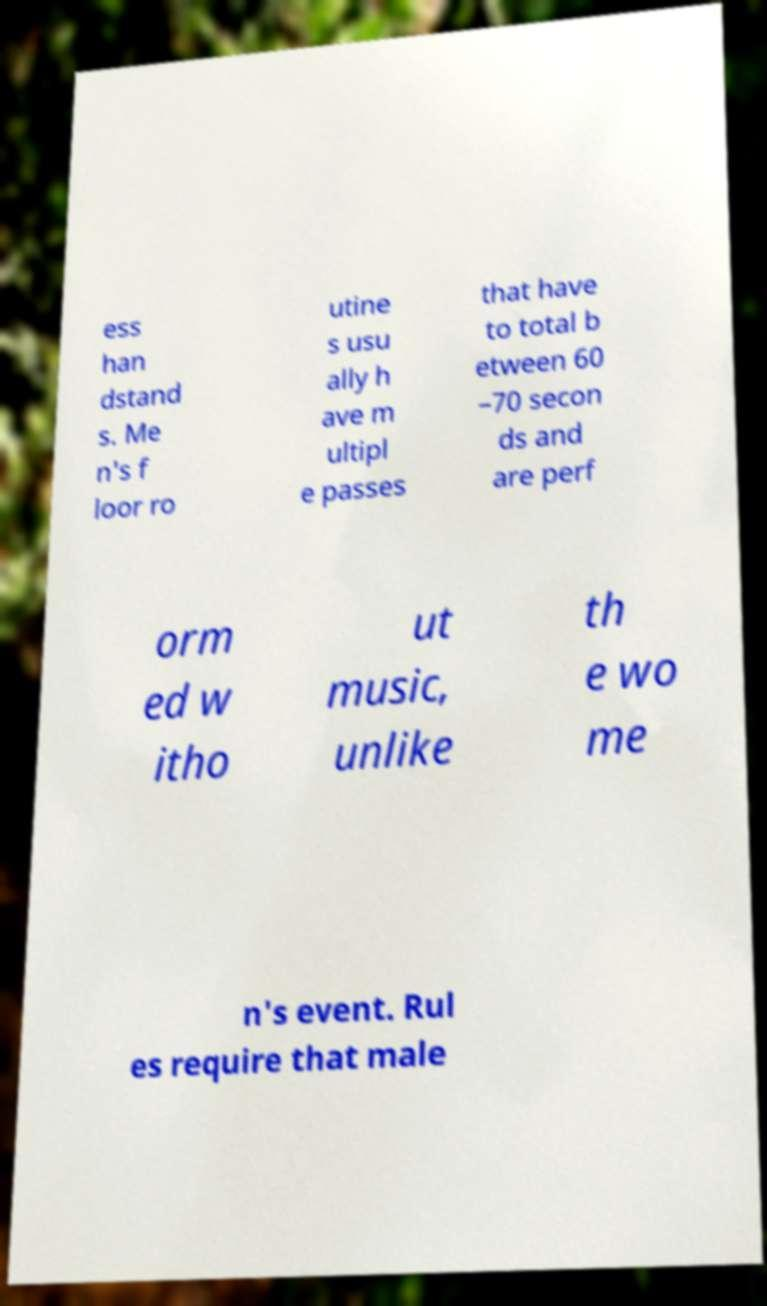Could you assist in decoding the text presented in this image and type it out clearly? ess han dstand s. Me n's f loor ro utine s usu ally h ave m ultipl e passes that have to total b etween 60 –70 secon ds and are perf orm ed w itho ut music, unlike th e wo me n's event. Rul es require that male 